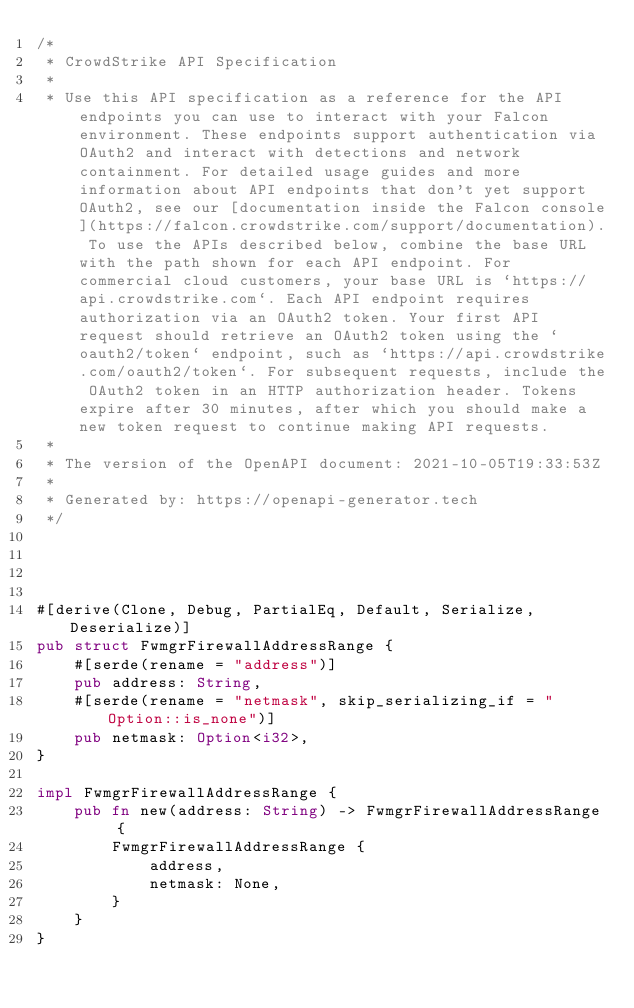<code> <loc_0><loc_0><loc_500><loc_500><_Rust_>/*
 * CrowdStrike API Specification
 *
 * Use this API specification as a reference for the API endpoints you can use to interact with your Falcon environment. These endpoints support authentication via OAuth2 and interact with detections and network containment. For detailed usage guides and more information about API endpoints that don't yet support OAuth2, see our [documentation inside the Falcon console](https://falcon.crowdstrike.com/support/documentation). To use the APIs described below, combine the base URL with the path shown for each API endpoint. For commercial cloud customers, your base URL is `https://api.crowdstrike.com`. Each API endpoint requires authorization via an OAuth2 token. Your first API request should retrieve an OAuth2 token using the `oauth2/token` endpoint, such as `https://api.crowdstrike.com/oauth2/token`. For subsequent requests, include the OAuth2 token in an HTTP authorization header. Tokens expire after 30 minutes, after which you should make a new token request to continue making API requests.
 *
 * The version of the OpenAPI document: 2021-10-05T19:33:53Z
 * 
 * Generated by: https://openapi-generator.tech
 */




#[derive(Clone, Debug, PartialEq, Default, Serialize, Deserialize)]
pub struct FwmgrFirewallAddressRange {
    #[serde(rename = "address")]
    pub address: String,
    #[serde(rename = "netmask", skip_serializing_if = "Option::is_none")]
    pub netmask: Option<i32>,
}

impl FwmgrFirewallAddressRange {
    pub fn new(address: String) -> FwmgrFirewallAddressRange {
        FwmgrFirewallAddressRange {
            address,
            netmask: None,
        }
    }
}


</code> 